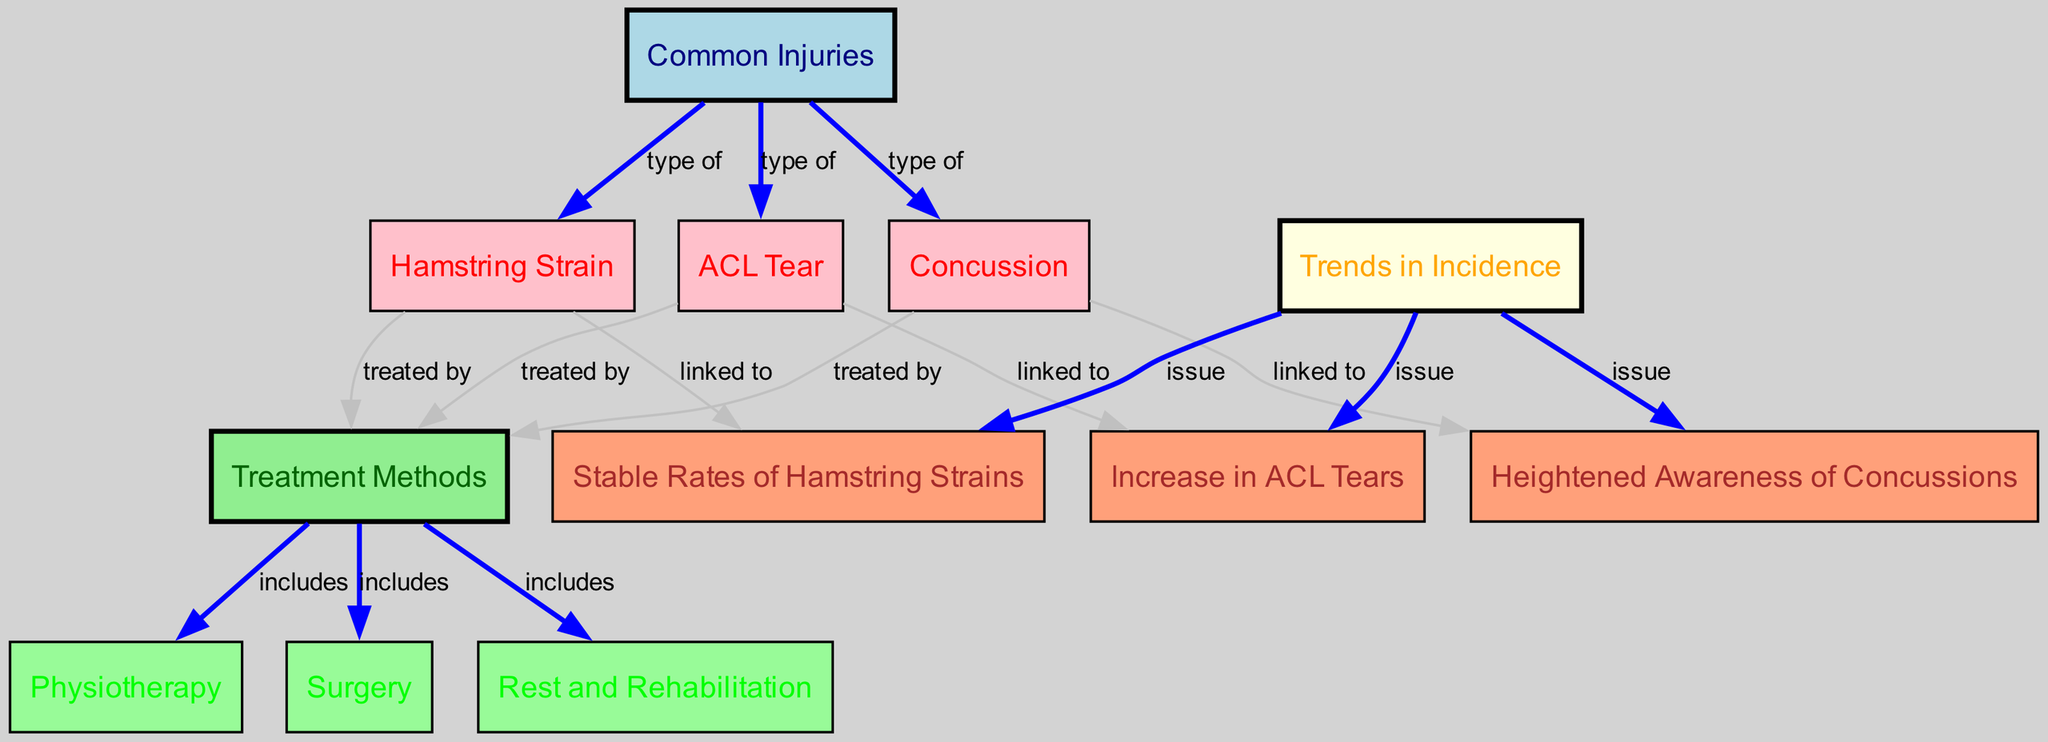What are the three common injuries identified in the diagram? The diagram includes three nodes categorized as common injuries: Hamstring Strain, ACL Tear, and Concussion. These nodes are directly linked to the "Common Injuries" node.
Answer: Hamstring Strain, ACL Tear, Concussion How many treatment methods are represented in the diagram? The diagram shows three treatment methods linked to the "Treatment Methods" node: Physiotherapy, Surgery, and Rest and Rehabilitation. Thus, there are three treatment methods represented.
Answer: 3 Which common injury is treated by surgery? According to the diagram, both ACL Tear and Concussion are connected to the "Treatment Methods" node with the edge labeled "treated by," which includes Surgery. Thus, ACL Tear is specifically treated by surgery.
Answer: ACL Tear What trend is linked to the increase in ACL tears? The diagram indicates that the "Increase in ACL Tears" is directly linked to the "Trends in Incidence" node. This clearly shows that the increase in ACL tears is a noted issue.
Answer: Increase in ACL Tears How many types of injuries are related to heightened awareness of concussions? The diagram shows that three types of injuries are directly related to the node representing heightened awareness of concussions, specifically linked through the edges labeled "linked to," which include Concussion itself.
Answer: 1 Which injury has stable rates according to the trends in incidence? The diagram mentions that "Stable Rates of Hamstring Strains" is an issue in the "Trends in Incidence" node. Therefore, the injury with stable rates is specifically the Hamstring Strain.
Answer: Hamstring Strain What are the methods included in the treatment of common injuries? The diagram outlines three specific methods under the "Treatment Methods" node: Physiotherapy, Surgery, and Rest and Rehabilitation. These methods are linked to the common injuries discussed.
Answer: Physiotherapy, Surgery, Rest and Rehabilitation Which common injury is linked to heightened awareness of concussions? The diagram explicitly connects the "Concussion" injury to the trend of "Heightened Awareness of Concussions," indicating a direct relationship between them.
Answer: Concussion 